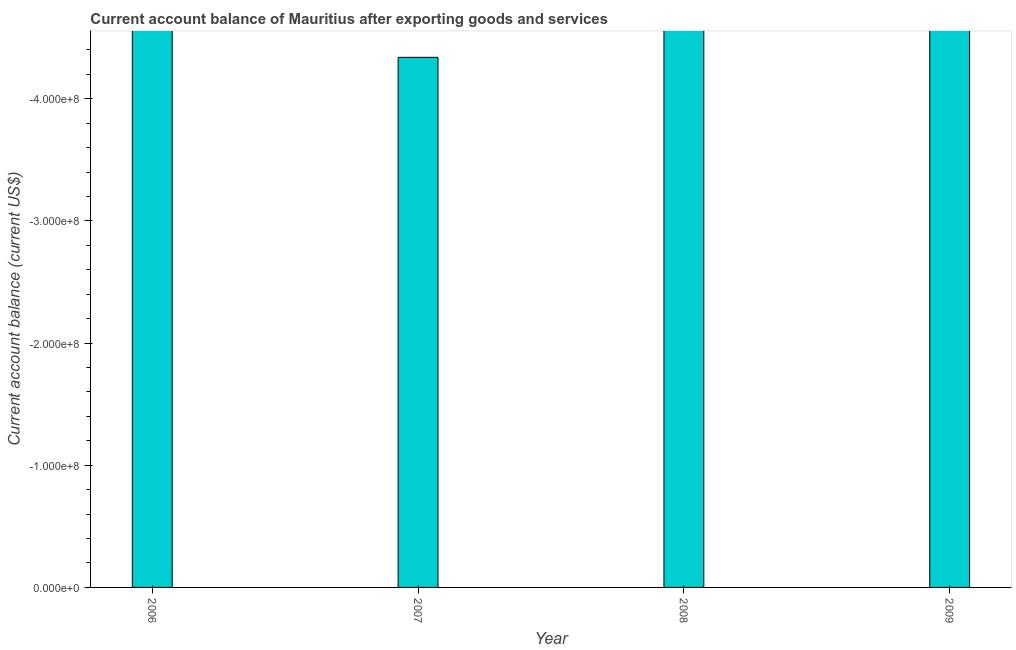Does the graph contain any zero values?
Offer a terse response. Yes. Does the graph contain grids?
Ensure brevity in your answer.  No. What is the title of the graph?
Offer a terse response. Current account balance of Mauritius after exporting goods and services. What is the label or title of the Y-axis?
Your answer should be very brief. Current account balance (current US$). What is the current account balance in 2009?
Offer a very short reply. 0. Across all years, what is the minimum current account balance?
Make the answer very short. 0. In how many years, is the current account balance greater than -80000000 US$?
Provide a succinct answer. 0. How many bars are there?
Make the answer very short. 0. Are all the bars in the graph horizontal?
Offer a terse response. No. Are the values on the major ticks of Y-axis written in scientific E-notation?
Your answer should be compact. Yes. What is the Current account balance (current US$) of 2006?
Make the answer very short. 0. What is the Current account balance (current US$) in 2007?
Make the answer very short. 0. What is the Current account balance (current US$) of 2008?
Your answer should be compact. 0. 